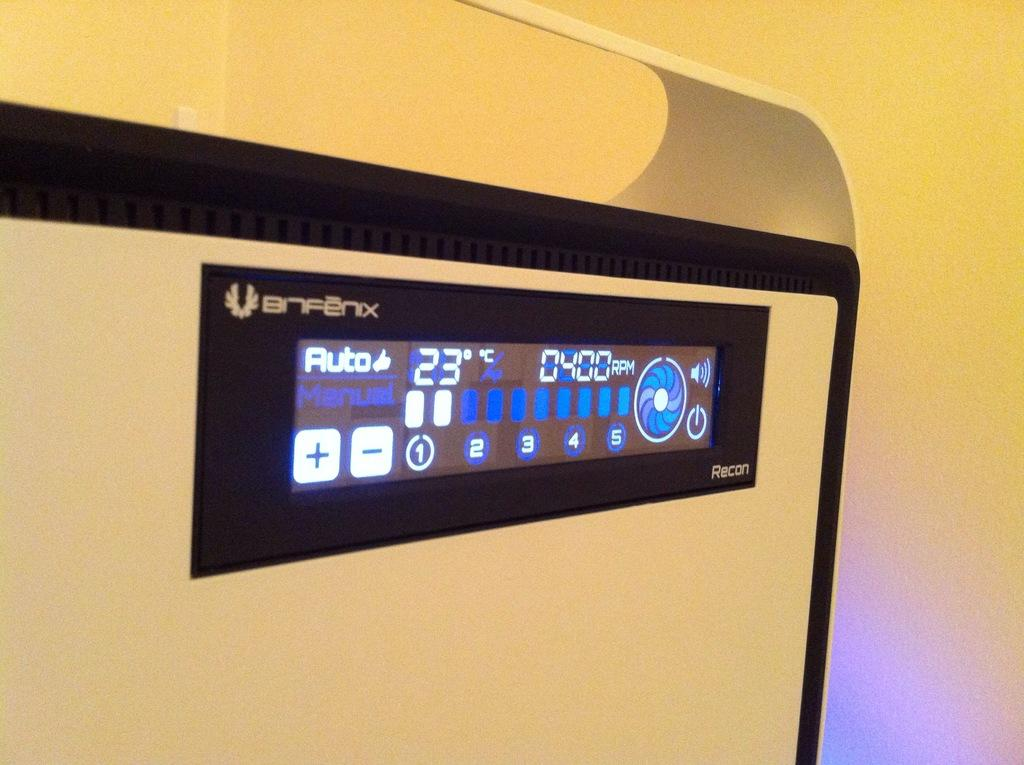<image>
Write a terse but informative summary of the picture. some sort of machine with an auto setting 